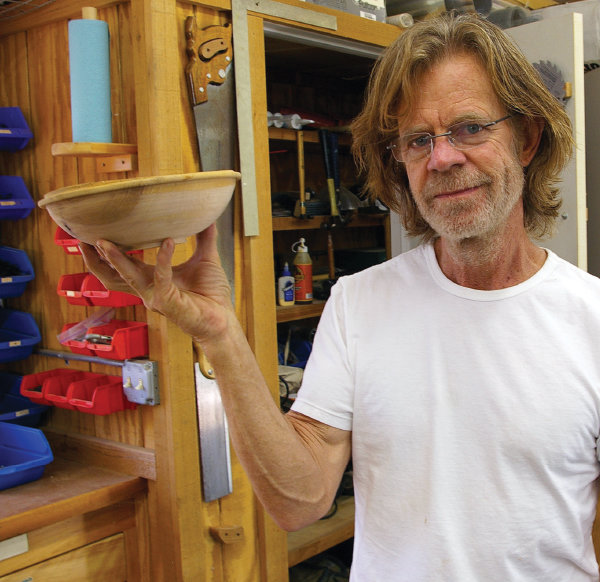What woodworking project can be seen in this image? The individual in the image is proudly holding a finished wooden bowl, which appears to be a handcrafted item from the workshop. The bowl showcases the natural wood grain and indicates a project that involves turning on a lathe, a common woodworking technique for creating rounded objects. 